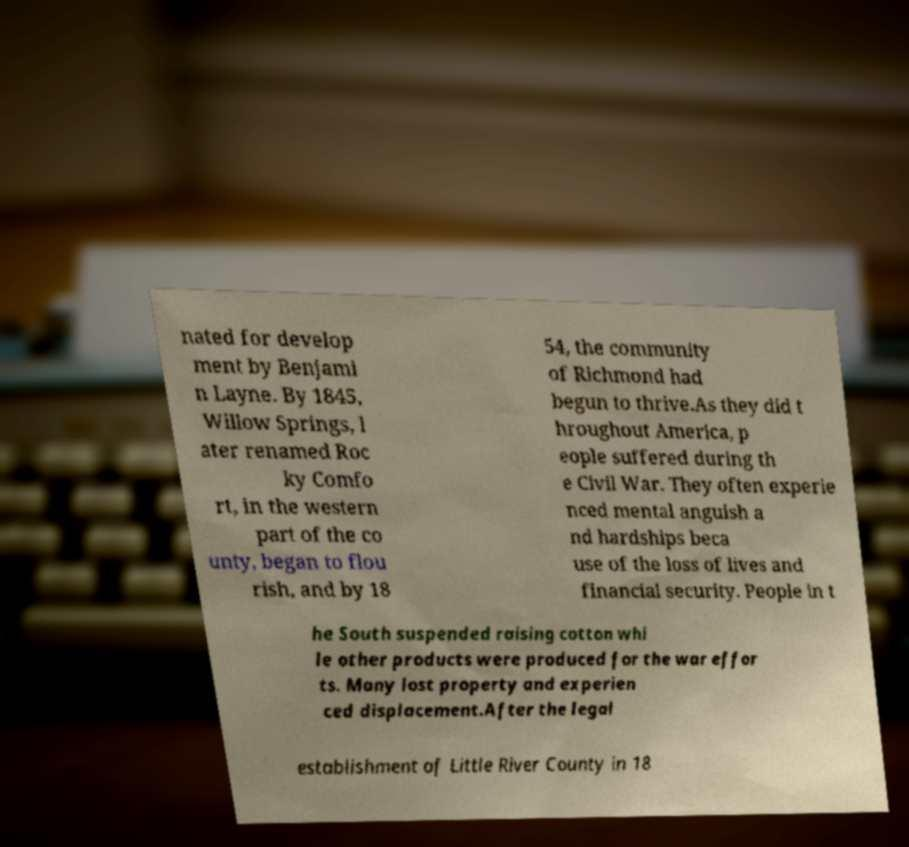For documentation purposes, I need the text within this image transcribed. Could you provide that? nated for develop ment by Benjami n Layne. By 1845, Willow Springs, l ater renamed Roc ky Comfo rt, in the western part of the co unty, began to flou rish, and by 18 54, the community of Richmond had begun to thrive.As they did t hroughout America, p eople suffered during th e Civil War. They often experie nced mental anguish a nd hardships beca use of the loss of lives and financial security. People in t he South suspended raising cotton whi le other products were produced for the war effor ts. Many lost property and experien ced displacement.After the legal establishment of Little River County in 18 